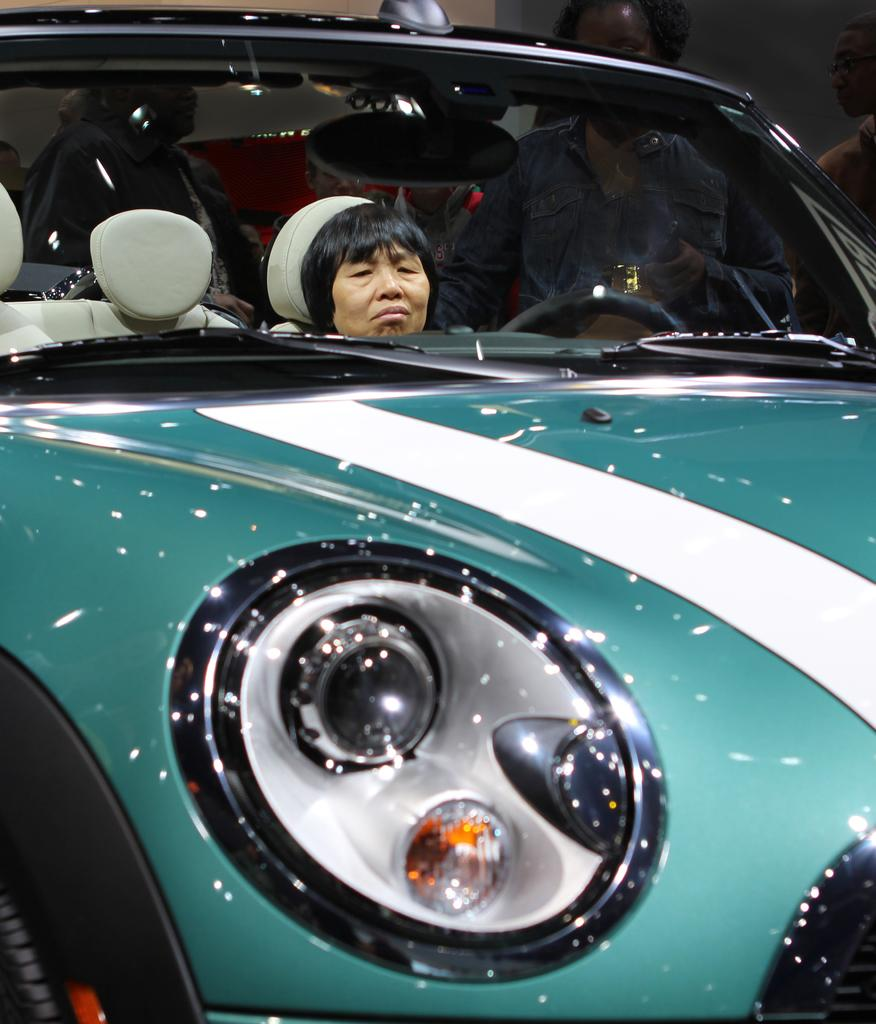What is the main subject of the image? The main subject of the image is a person sitting in a car. Where is the person sitting in the car located? The person is in the middle of the image. What can be seen in the background of the image? There are people standing in the background of the image. What type of ship can be seen sailing in the background of the image? There is no ship present in the image; it features a person sitting in a car with people standing in the background. 